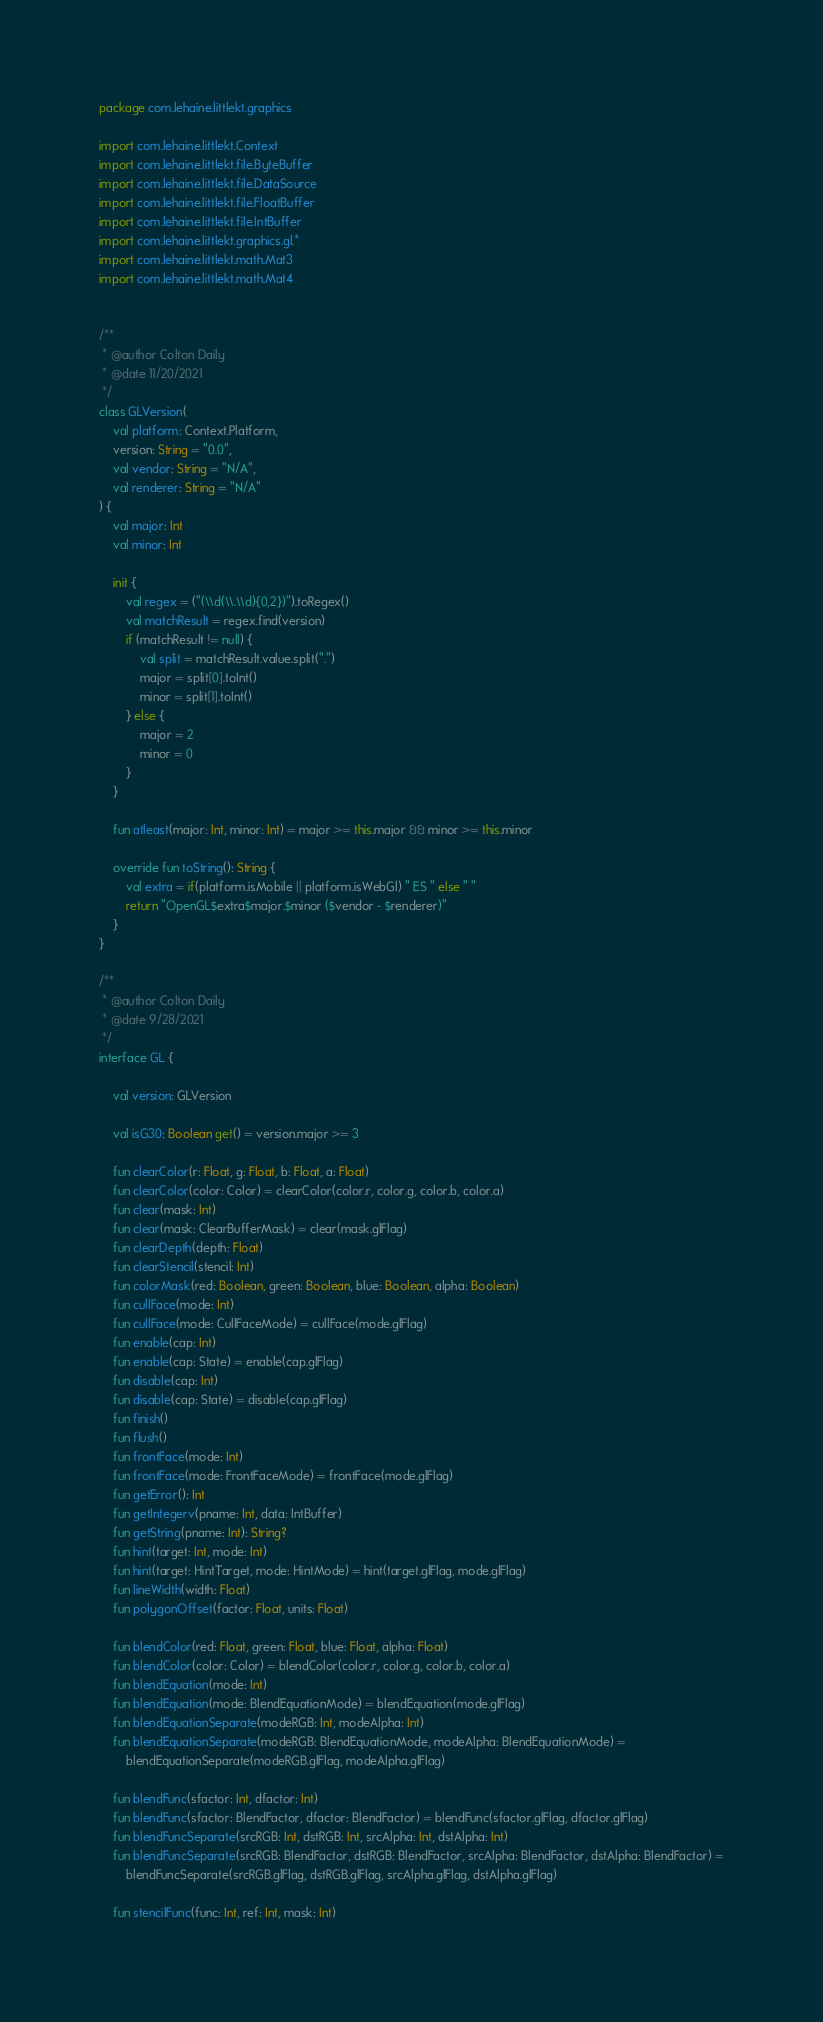Convert code to text. <code><loc_0><loc_0><loc_500><loc_500><_Kotlin_>package com.lehaine.littlekt.graphics

import com.lehaine.littlekt.Context
import com.lehaine.littlekt.file.ByteBuffer
import com.lehaine.littlekt.file.DataSource
import com.lehaine.littlekt.file.FloatBuffer
import com.lehaine.littlekt.file.IntBuffer
import com.lehaine.littlekt.graphics.gl.*
import com.lehaine.littlekt.math.Mat3
import com.lehaine.littlekt.math.Mat4


/**
 * @author Colton Daily
 * @date 11/20/2021
 */
class GLVersion(
    val platform: Context.Platform,
    version: String = "0.0",
    val vendor: String = "N/A",
    val renderer: String = "N/A"
) {
    val major: Int
    val minor: Int

    init {
        val regex = ("(\\d(\\.\\d){0,2})").toRegex()
        val matchResult = regex.find(version)
        if (matchResult != null) {
            val split = matchResult.value.split(".")
            major = split[0].toInt()
            minor = split[1].toInt()
        } else {
            major = 2
            minor = 0
        }
    }

    fun atleast(major: Int, minor: Int) = major >= this.major && minor >= this.minor

    override fun toString(): String {
        val extra = if(platform.isMobile || platform.isWebGl) " ES " else " "
        return "OpenGL$extra$major.$minor ($vendor - $renderer)"
    }
}

/**
 * @author Colton Daily
 * @date 9/28/2021
 */
interface GL {

    val version: GLVersion

    val isG30: Boolean get() = version.major >= 3

    fun clearColor(r: Float, g: Float, b: Float, a: Float)
    fun clearColor(color: Color) = clearColor(color.r, color.g, color.b, color.a)
    fun clear(mask: Int)
    fun clear(mask: ClearBufferMask) = clear(mask.glFlag)
    fun clearDepth(depth: Float)
    fun clearStencil(stencil: Int)
    fun colorMask(red: Boolean, green: Boolean, blue: Boolean, alpha: Boolean)
    fun cullFace(mode: Int)
    fun cullFace(mode: CullFaceMode) = cullFace(mode.glFlag)
    fun enable(cap: Int)
    fun enable(cap: State) = enable(cap.glFlag)
    fun disable(cap: Int)
    fun disable(cap: State) = disable(cap.glFlag)
    fun finish()
    fun flush()
    fun frontFace(mode: Int)
    fun frontFace(mode: FrontFaceMode) = frontFace(mode.glFlag)
    fun getError(): Int
    fun getIntegerv(pname: Int, data: IntBuffer)
    fun getString(pname: Int): String?
    fun hint(target: Int, mode: Int)
    fun hint(target: HintTarget, mode: HintMode) = hint(target.glFlag, mode.glFlag)
    fun lineWidth(width: Float)
    fun polygonOffset(factor: Float, units: Float)

    fun blendColor(red: Float, green: Float, blue: Float, alpha: Float)
    fun blendColor(color: Color) = blendColor(color.r, color.g, color.b, color.a)
    fun blendEquation(mode: Int)
    fun blendEquation(mode: BlendEquationMode) = blendEquation(mode.glFlag)
    fun blendEquationSeparate(modeRGB: Int, modeAlpha: Int)
    fun blendEquationSeparate(modeRGB: BlendEquationMode, modeAlpha: BlendEquationMode) =
        blendEquationSeparate(modeRGB.glFlag, modeAlpha.glFlag)

    fun blendFunc(sfactor: Int, dfactor: Int)
    fun blendFunc(sfactor: BlendFactor, dfactor: BlendFactor) = blendFunc(sfactor.glFlag, dfactor.glFlag)
    fun blendFuncSeparate(srcRGB: Int, dstRGB: Int, srcAlpha: Int, dstAlpha: Int)
    fun blendFuncSeparate(srcRGB: BlendFactor, dstRGB: BlendFactor, srcAlpha: BlendFactor, dstAlpha: BlendFactor) =
        blendFuncSeparate(srcRGB.glFlag, dstRGB.glFlag, srcAlpha.glFlag, dstAlpha.glFlag)

    fun stencilFunc(func: Int, ref: Int, mask: Int)</code> 